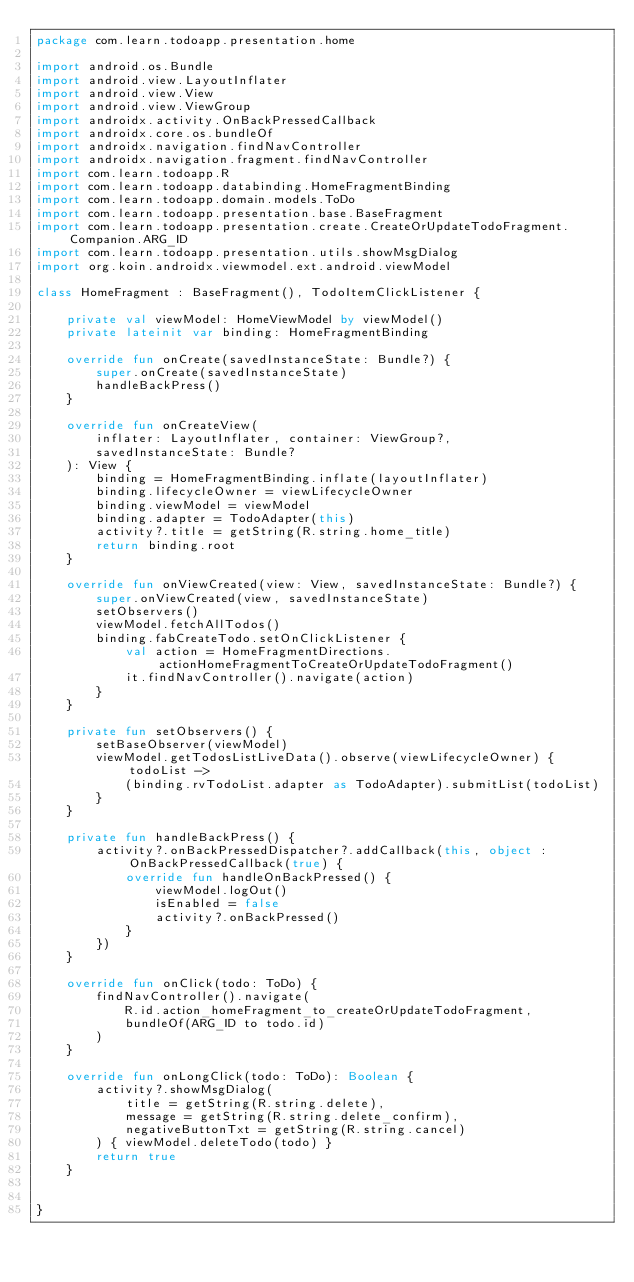Convert code to text. <code><loc_0><loc_0><loc_500><loc_500><_Kotlin_>package com.learn.todoapp.presentation.home

import android.os.Bundle
import android.view.LayoutInflater
import android.view.View
import android.view.ViewGroup
import androidx.activity.OnBackPressedCallback
import androidx.core.os.bundleOf
import androidx.navigation.findNavController
import androidx.navigation.fragment.findNavController
import com.learn.todoapp.R
import com.learn.todoapp.databinding.HomeFragmentBinding
import com.learn.todoapp.domain.models.ToDo
import com.learn.todoapp.presentation.base.BaseFragment
import com.learn.todoapp.presentation.create.CreateOrUpdateTodoFragment.Companion.ARG_ID
import com.learn.todoapp.presentation.utils.showMsgDialog
import org.koin.androidx.viewmodel.ext.android.viewModel

class HomeFragment : BaseFragment(), TodoItemClickListener {

    private val viewModel: HomeViewModel by viewModel()
    private lateinit var binding: HomeFragmentBinding

    override fun onCreate(savedInstanceState: Bundle?) {
        super.onCreate(savedInstanceState)
        handleBackPress()
    }

    override fun onCreateView(
        inflater: LayoutInflater, container: ViewGroup?,
        savedInstanceState: Bundle?
    ): View {
        binding = HomeFragmentBinding.inflate(layoutInflater)
        binding.lifecycleOwner = viewLifecycleOwner
        binding.viewModel = viewModel
        binding.adapter = TodoAdapter(this)
        activity?.title = getString(R.string.home_title)
        return binding.root
    }

    override fun onViewCreated(view: View, savedInstanceState: Bundle?) {
        super.onViewCreated(view, savedInstanceState)
        setObservers()
        viewModel.fetchAllTodos()
        binding.fabCreateTodo.setOnClickListener {
            val action = HomeFragmentDirections.actionHomeFragmentToCreateOrUpdateTodoFragment()
            it.findNavController().navigate(action)
        }
    }

    private fun setObservers() {
        setBaseObserver(viewModel)
        viewModel.getTodosListLiveData().observe(viewLifecycleOwner) { todoList ->
            (binding.rvTodoList.adapter as TodoAdapter).submitList(todoList)
        }
    }

    private fun handleBackPress() {
        activity?.onBackPressedDispatcher?.addCallback(this, object : OnBackPressedCallback(true) {
            override fun handleOnBackPressed() {
                viewModel.logOut()
                isEnabled = false
                activity?.onBackPressed()
            }
        })
    }

    override fun onClick(todo: ToDo) {
        findNavController().navigate(
            R.id.action_homeFragment_to_createOrUpdateTodoFragment,
            bundleOf(ARG_ID to todo.id)
        )
    }

    override fun onLongClick(todo: ToDo): Boolean {
        activity?.showMsgDialog(
            title = getString(R.string.delete),
            message = getString(R.string.delete_confirm),
            negativeButtonTxt = getString(R.string.cancel)
        ) { viewModel.deleteTodo(todo) }
        return true
    }


}</code> 